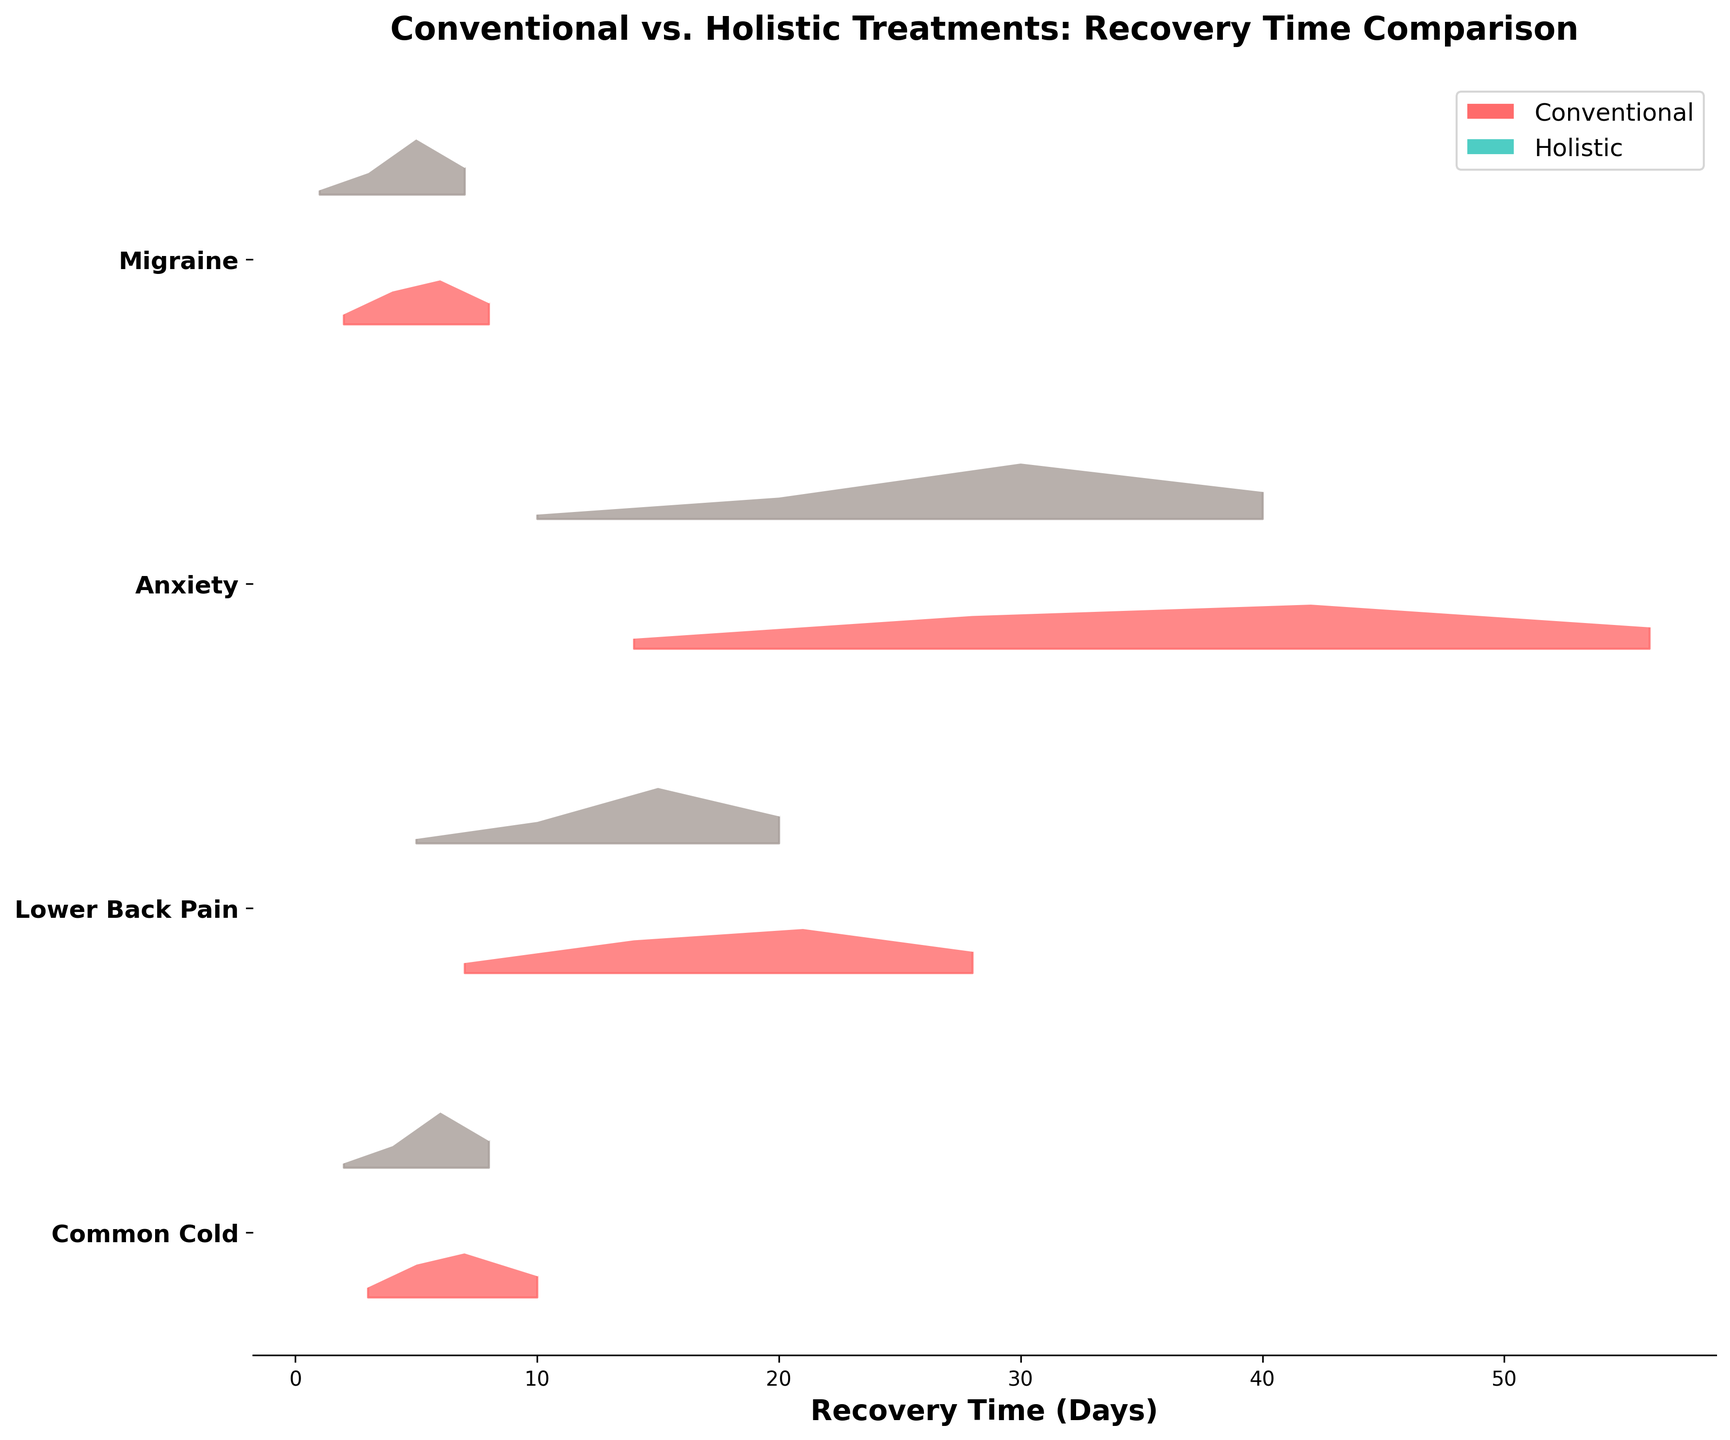What is the title of the plot? The title can be found at the top of the figure, and it reads "Conventional vs. Holistic Treatments: Recovery Time Comparison".
Answer: Conventional vs. Holistic Treatments: Recovery Time Comparison How many ailments are compared in the figure? The ailments are listed along the y-axis as different rows, and there are 4 unique ailments: Common Cold, Lower Back Pain, Anxiety, and Migraine.
Answer: 4 Which treatment shows a higher density of recovery around 6 days for Common Cold? For Common Cold at 6 days, the density for Holistic treatment is 0.5 and higher as compared to the Conventional treatment, which shows density at either 3 or 7 days but not specifically 6.
Answer: Holistic What is the density value for Conventional treatment of Anxiety at 42 days? The density values for Conventional treatment of Anxiety can be found at 28 and 42 days, and the density at 42 days is shown to be 0.4 on the figure.
Answer: 0.4 Which treatment generally leads to faster recovery from Migraines? By observing the x-axis (Recovery Time) and comparing the peaks of densities of both treatments, it's seen that Holistic treatment has higher density at earlier days (around 1-5 days) versus Conventional treatment (around 2-8 days).
Answer: Holistic How do the densities for Conventional and Holistic treatments compare for Lower Back Pain at 14 days? In the Ridgeline plot, for Lower Back Pain at 14 days, the density of Conventional treatment is 0.3 while the density for Holistic treatment does not show any significant peak at exactly that timeframe.
Answer: Higher for Conventional What appears to be the recovery duration with the highest density for Conventional treatment in Lower Back Pain? For Lower Back Pain, the highest density peak for Conventional treatment occurs at 21 days where the density reaches 0.4 as shown by the tall curve.
Answer: 21 days What’s the duration range where Holistic treatment shows a significant density for Anxiety recovery? Holistic treatment for Anxiety shows significant density values more prominently between 20 to 40 days as inferred from the relative height of the curves in this range.
Answer: 20 to 40 days For both treatments, which ailment shows recovery over the longest duration? Recovery durations can be inferred by examining the x-axis range each treatment's densities span across; Anxiety for both treatments spans from 28 to 56 days for Conventional and 20 to 40 days for Holistic.
Answer: Anxiety 